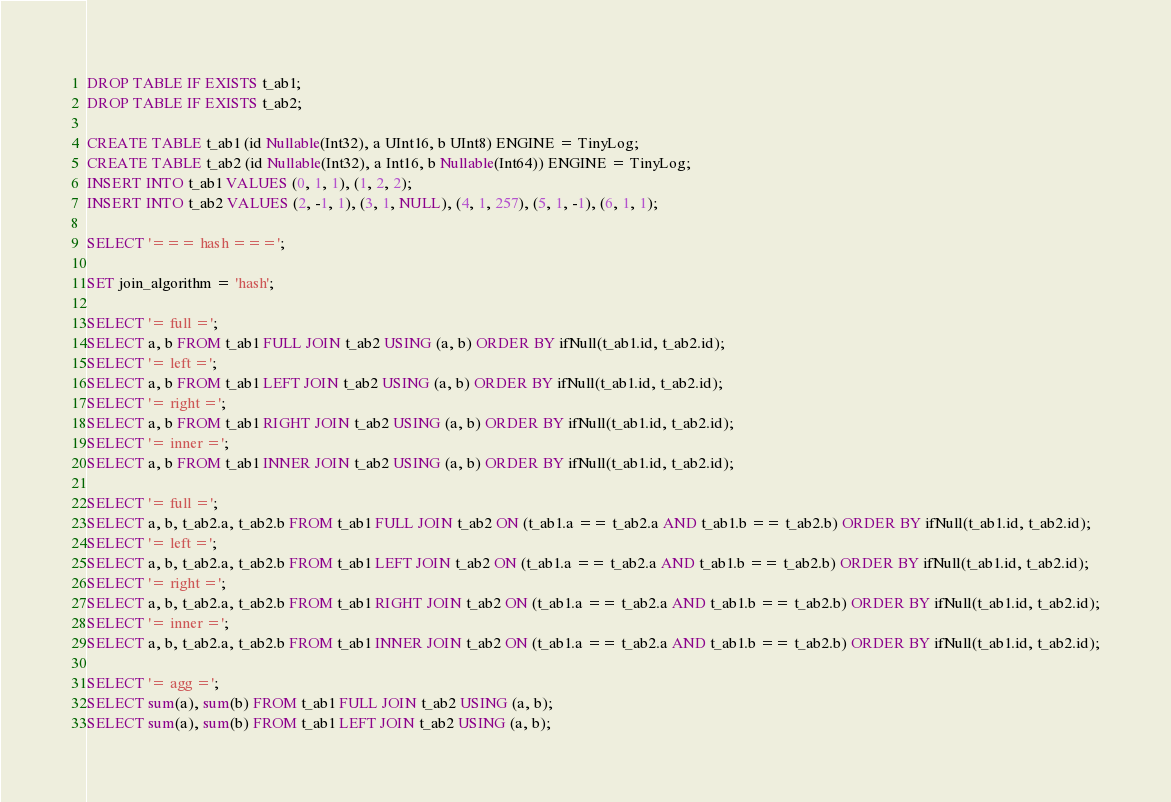Convert code to text. <code><loc_0><loc_0><loc_500><loc_500><_SQL_>DROP TABLE IF EXISTS t_ab1;
DROP TABLE IF EXISTS t_ab2;

CREATE TABLE t_ab1 (id Nullable(Int32), a UInt16, b UInt8) ENGINE = TinyLog;
CREATE TABLE t_ab2 (id Nullable(Int32), a Int16, b Nullable(Int64)) ENGINE = TinyLog;
INSERT INTO t_ab1 VALUES (0, 1, 1), (1, 2, 2);
INSERT INTO t_ab2 VALUES (2, -1, 1), (3, 1, NULL), (4, 1, 257), (5, 1, -1), (6, 1, 1);

SELECT '=== hash ===';

SET join_algorithm = 'hash';

SELECT '= full =';
SELECT a, b FROM t_ab1 FULL JOIN t_ab2 USING (a, b) ORDER BY ifNull(t_ab1.id, t_ab2.id);
SELECT '= left =';
SELECT a, b FROM t_ab1 LEFT JOIN t_ab2 USING (a, b) ORDER BY ifNull(t_ab1.id, t_ab2.id);
SELECT '= right =';
SELECT a, b FROM t_ab1 RIGHT JOIN t_ab2 USING (a, b) ORDER BY ifNull(t_ab1.id, t_ab2.id);
SELECT '= inner =';
SELECT a, b FROM t_ab1 INNER JOIN t_ab2 USING (a, b) ORDER BY ifNull(t_ab1.id, t_ab2.id);

SELECT '= full =';
SELECT a, b, t_ab2.a, t_ab2.b FROM t_ab1 FULL JOIN t_ab2 ON (t_ab1.a == t_ab2.a AND t_ab1.b == t_ab2.b) ORDER BY ifNull(t_ab1.id, t_ab2.id);
SELECT '= left =';
SELECT a, b, t_ab2.a, t_ab2.b FROM t_ab1 LEFT JOIN t_ab2 ON (t_ab1.a == t_ab2.a AND t_ab1.b == t_ab2.b) ORDER BY ifNull(t_ab1.id, t_ab2.id);
SELECT '= right =';
SELECT a, b, t_ab2.a, t_ab2.b FROM t_ab1 RIGHT JOIN t_ab2 ON (t_ab1.a == t_ab2.a AND t_ab1.b == t_ab2.b) ORDER BY ifNull(t_ab1.id, t_ab2.id);
SELECT '= inner =';
SELECT a, b, t_ab2.a, t_ab2.b FROM t_ab1 INNER JOIN t_ab2 ON (t_ab1.a == t_ab2.a AND t_ab1.b == t_ab2.b) ORDER BY ifNull(t_ab1.id, t_ab2.id);

SELECT '= agg =';
SELECT sum(a), sum(b) FROM t_ab1 FULL JOIN t_ab2 USING (a, b);
SELECT sum(a), sum(b) FROM t_ab1 LEFT JOIN t_ab2 USING (a, b);</code> 